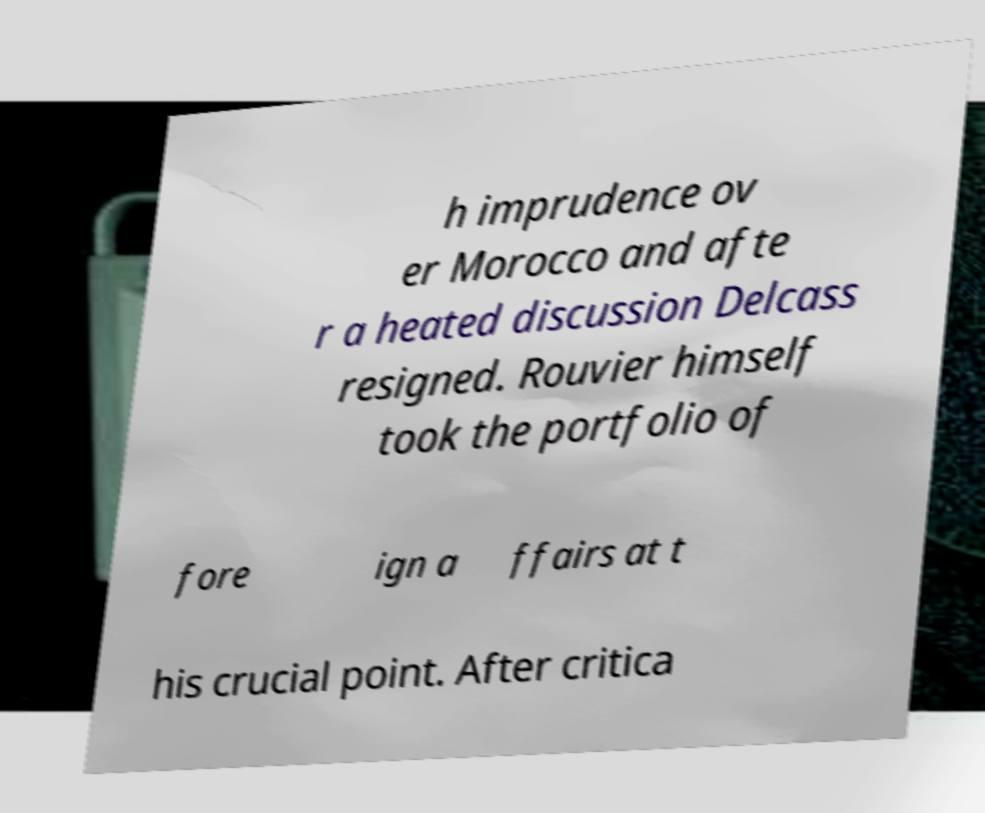There's text embedded in this image that I need extracted. Can you transcribe it verbatim? h imprudence ov er Morocco and afte r a heated discussion Delcass resigned. Rouvier himself took the portfolio of fore ign a ffairs at t his crucial point. After critica 